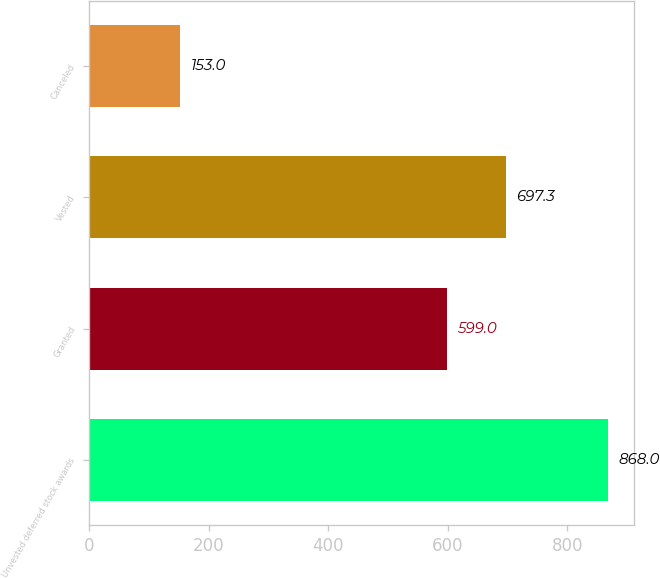<chart> <loc_0><loc_0><loc_500><loc_500><bar_chart><fcel>Unvested deferred stock awards<fcel>Granted<fcel>Vested<fcel>Canceled<nl><fcel>868<fcel>599<fcel>697.3<fcel>153<nl></chart> 